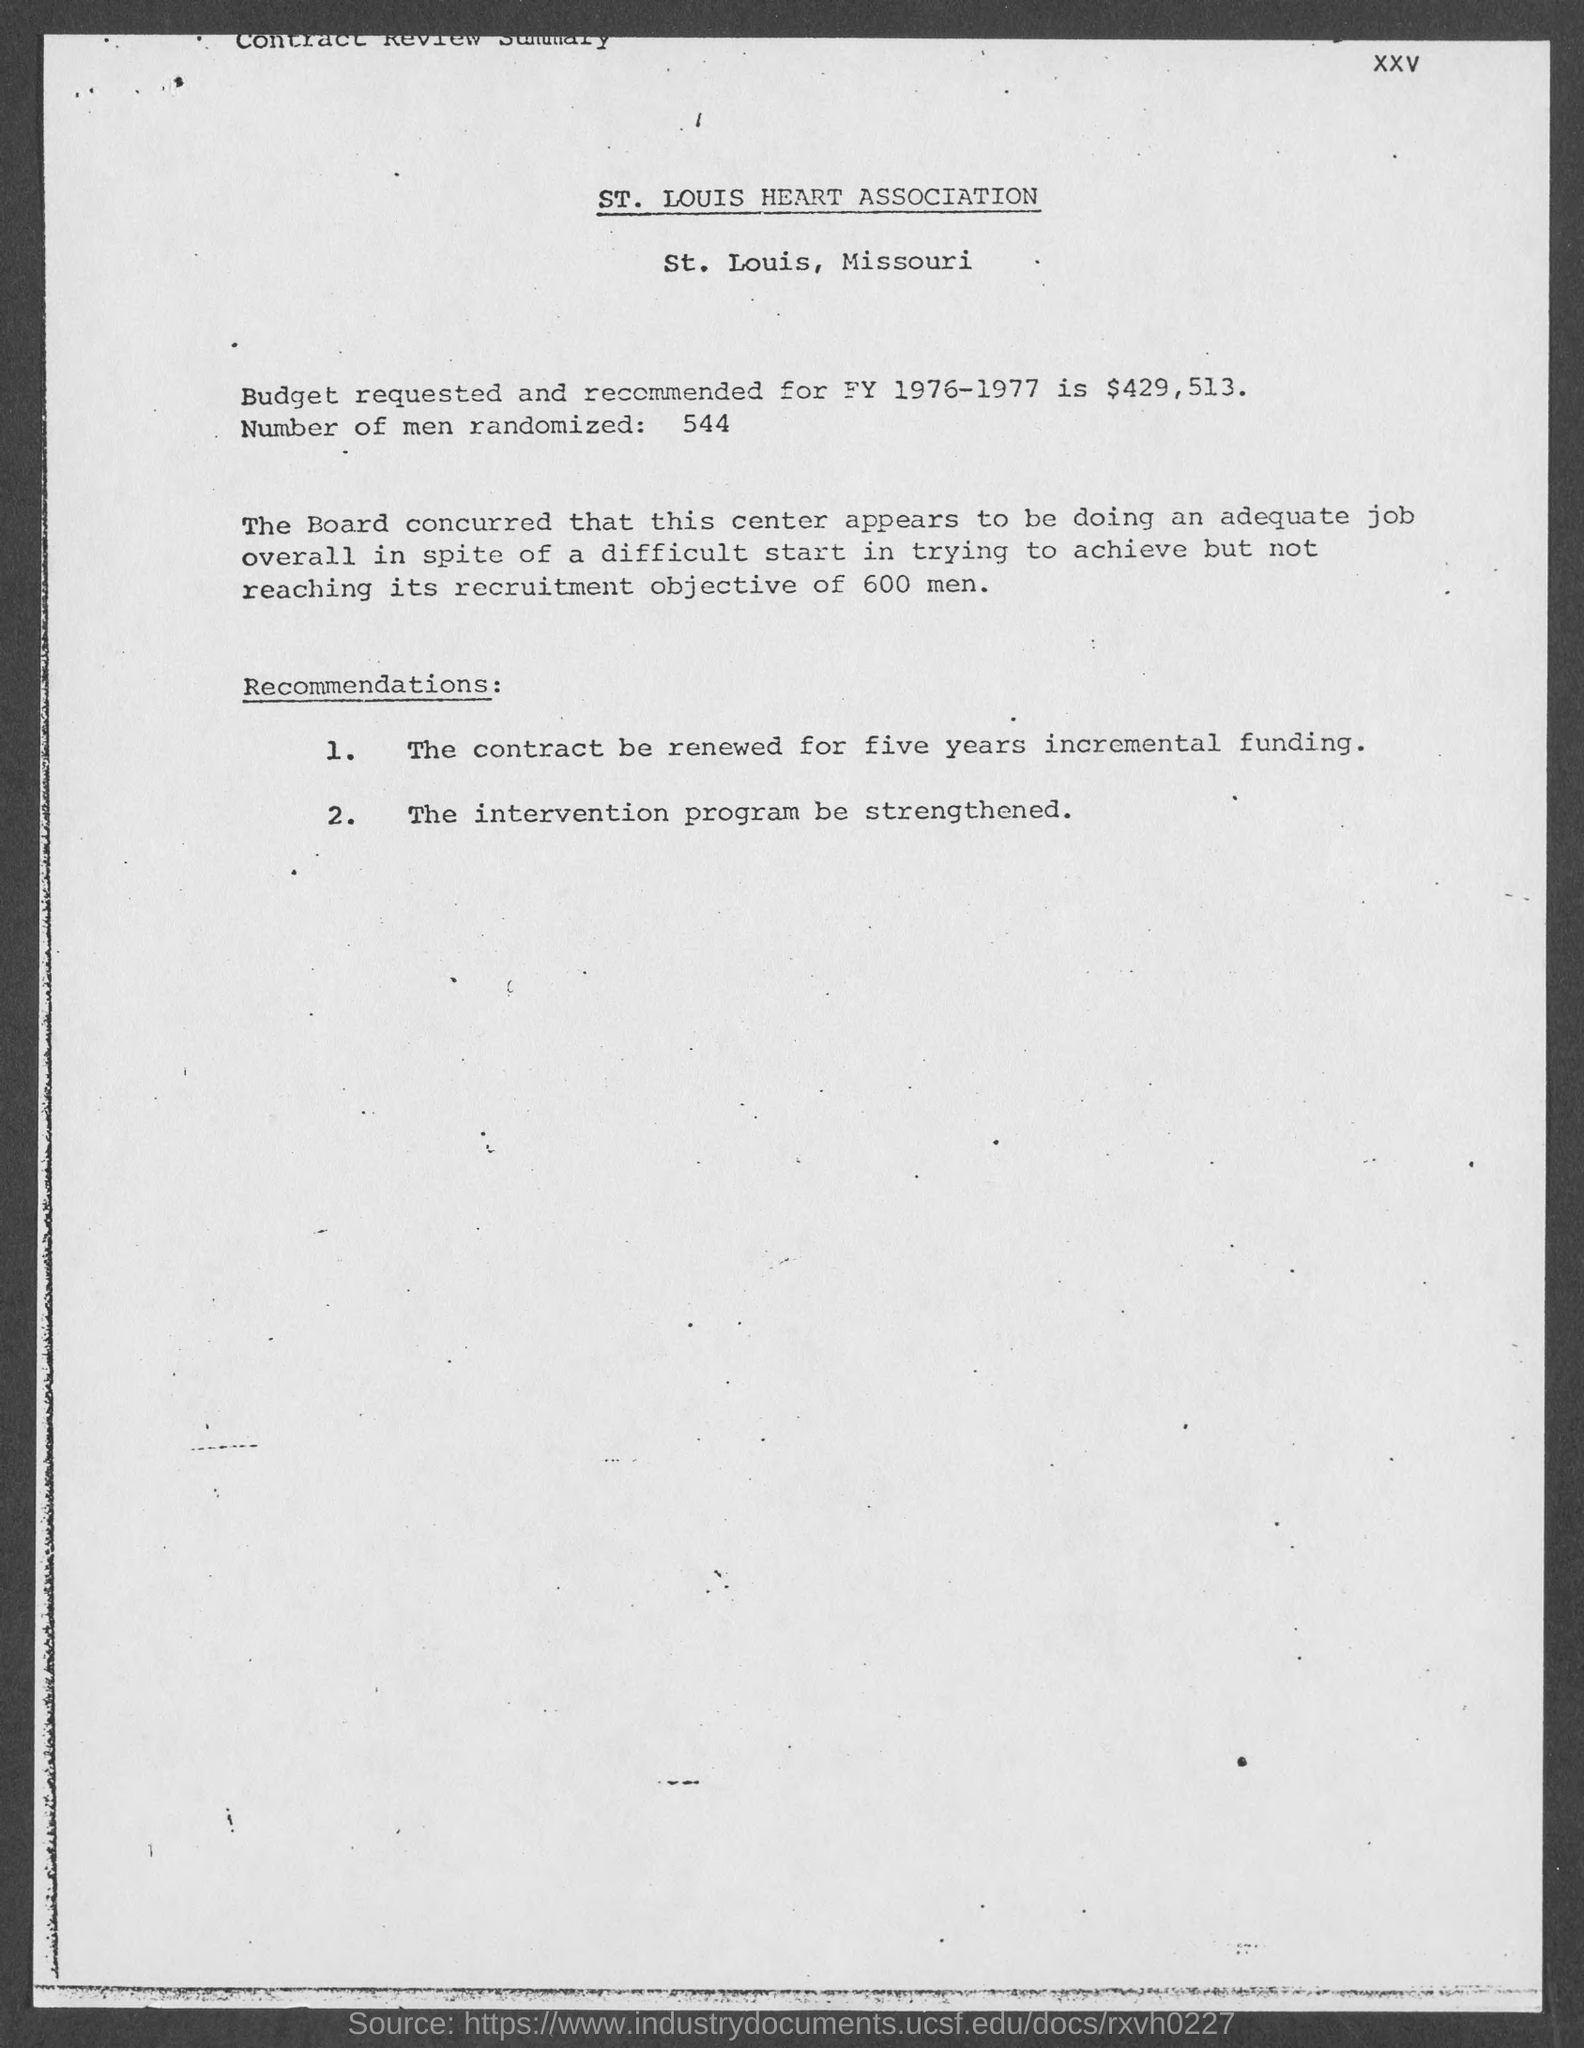Which association's contract review summary is this?
Offer a very short reply. ST. LOUIS HEART ASSOCIATION. What is the number of men randomized as per the document?
Make the answer very short. 544. 